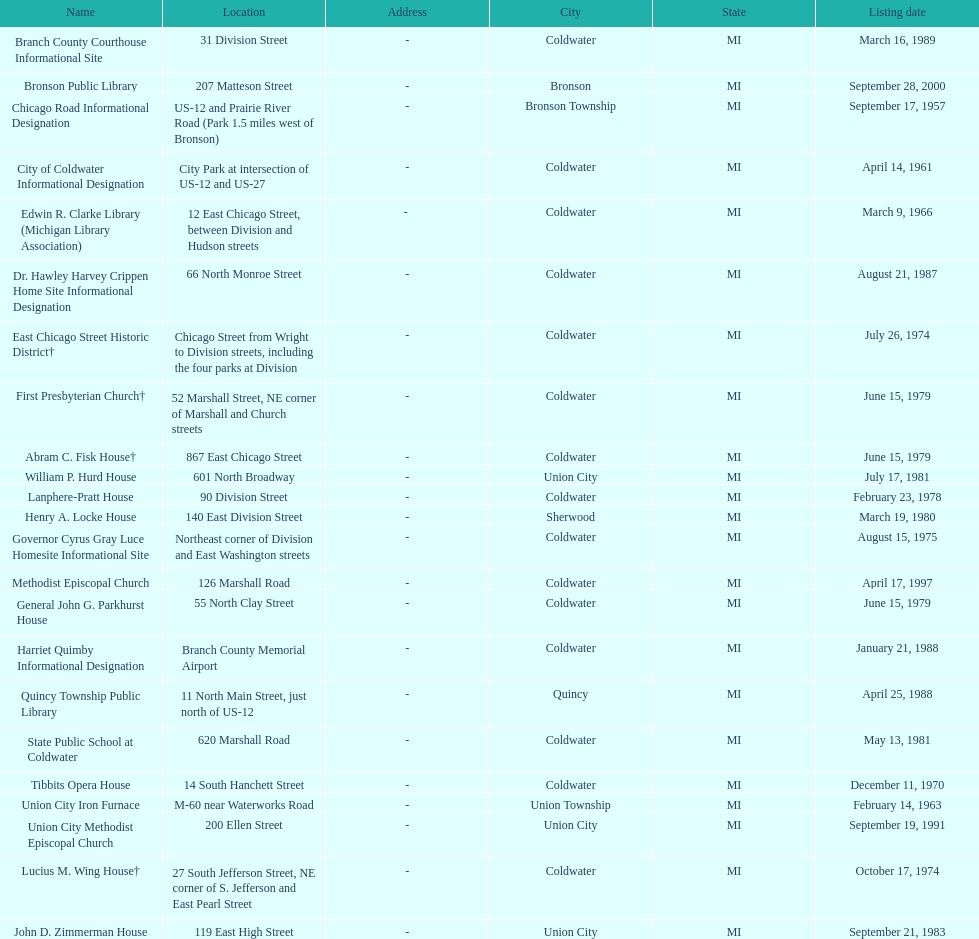In coldwater, how many sites can be found? 15. 